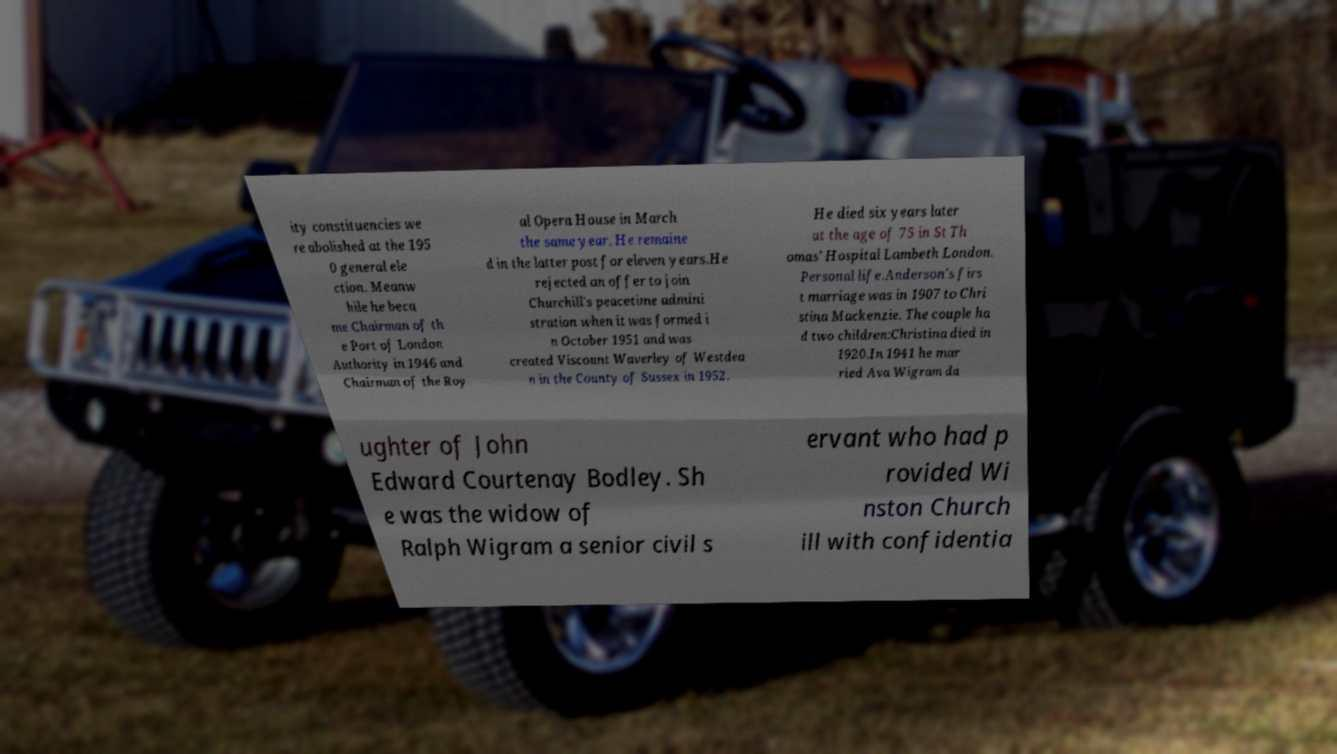For documentation purposes, I need the text within this image transcribed. Could you provide that? ity constituencies we re abolished at the 195 0 general ele ction. Meanw hile he beca me Chairman of th e Port of London Authority in 1946 and Chairman of the Roy al Opera House in March the same year. He remaine d in the latter post for eleven years.He rejected an offer to join Churchill's peacetime admini stration when it was formed i n October 1951 and was created Viscount Waverley of Westdea n in the County of Sussex in 1952. He died six years later at the age of 75 in St Th omas' Hospital Lambeth London. Personal life.Anderson's firs t marriage was in 1907 to Chri stina Mackenzie. The couple ha d two children:Christina died in 1920.In 1941 he mar ried Ava Wigram da ughter of John Edward Courtenay Bodley. Sh e was the widow of Ralph Wigram a senior civil s ervant who had p rovided Wi nston Church ill with confidentia 